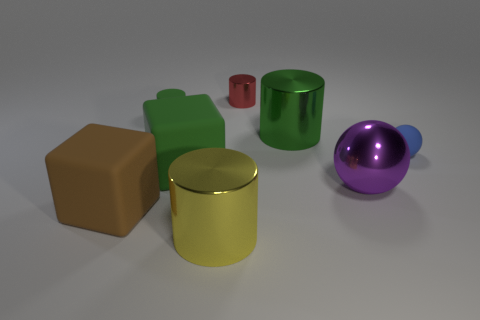Are there any other things that have the same color as the large ball?
Provide a short and direct response. No. Does the small red metal object have the same shape as the small blue rubber object?
Your response must be concise. No. Does the purple metallic thing have the same size as the green rubber cylinder?
Ensure brevity in your answer.  No. There is a shiny object that is in front of the purple metallic object; is it the same size as the red metal thing?
Give a very brief answer. No. What color is the tiny matte thing behind the tiny blue matte thing?
Make the answer very short. Green. How many things are there?
Ensure brevity in your answer.  8. There is a brown thing that is made of the same material as the tiny green cylinder; what shape is it?
Make the answer very short. Cube. Do the tiny thing right of the small red metal cylinder and the large shiny object left of the small metallic thing have the same color?
Make the answer very short. No. Are there the same number of small balls that are to the left of the green matte block and big purple metal blocks?
Your answer should be very brief. Yes. What number of large matte objects are right of the tiny rubber cylinder?
Your answer should be very brief. 1. 